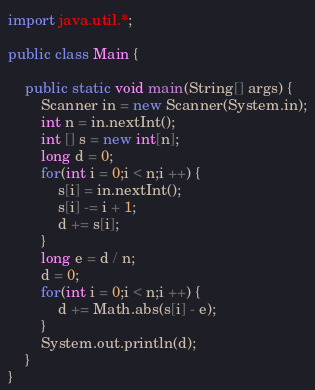<code> <loc_0><loc_0><loc_500><loc_500><_Java_>import java.util.*;

public class Main {
	
	public static void main(String[] args) {
		Scanner in = new Scanner(System.in);
		int n = in.nextInt();
		int [] s = new int[n];
		long d = 0;
		for(int i = 0;i < n;i ++) {
			s[i] = in.nextInt();
			s[i] -= i + 1;
			d += s[i];
		}
		long e = d / n;
		d = 0;
		for(int i = 0;i < n;i ++) {
			d += Math.abs(s[i] - e);
		}
		System.out.println(d);
	}
}
</code> 